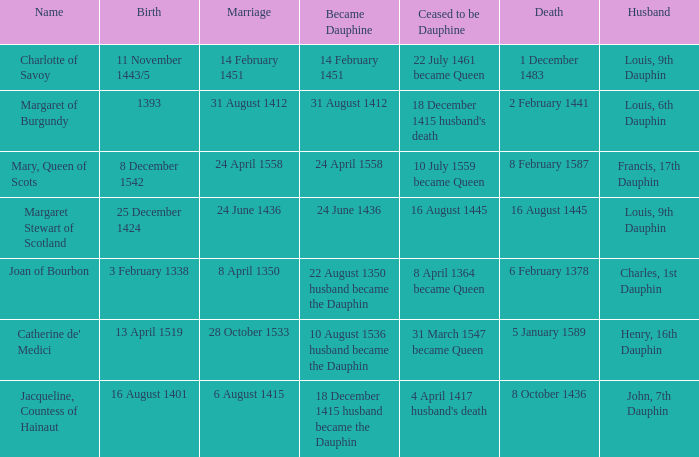When was the death of the person with husband charles, 1st dauphin? 6 February 1378. 